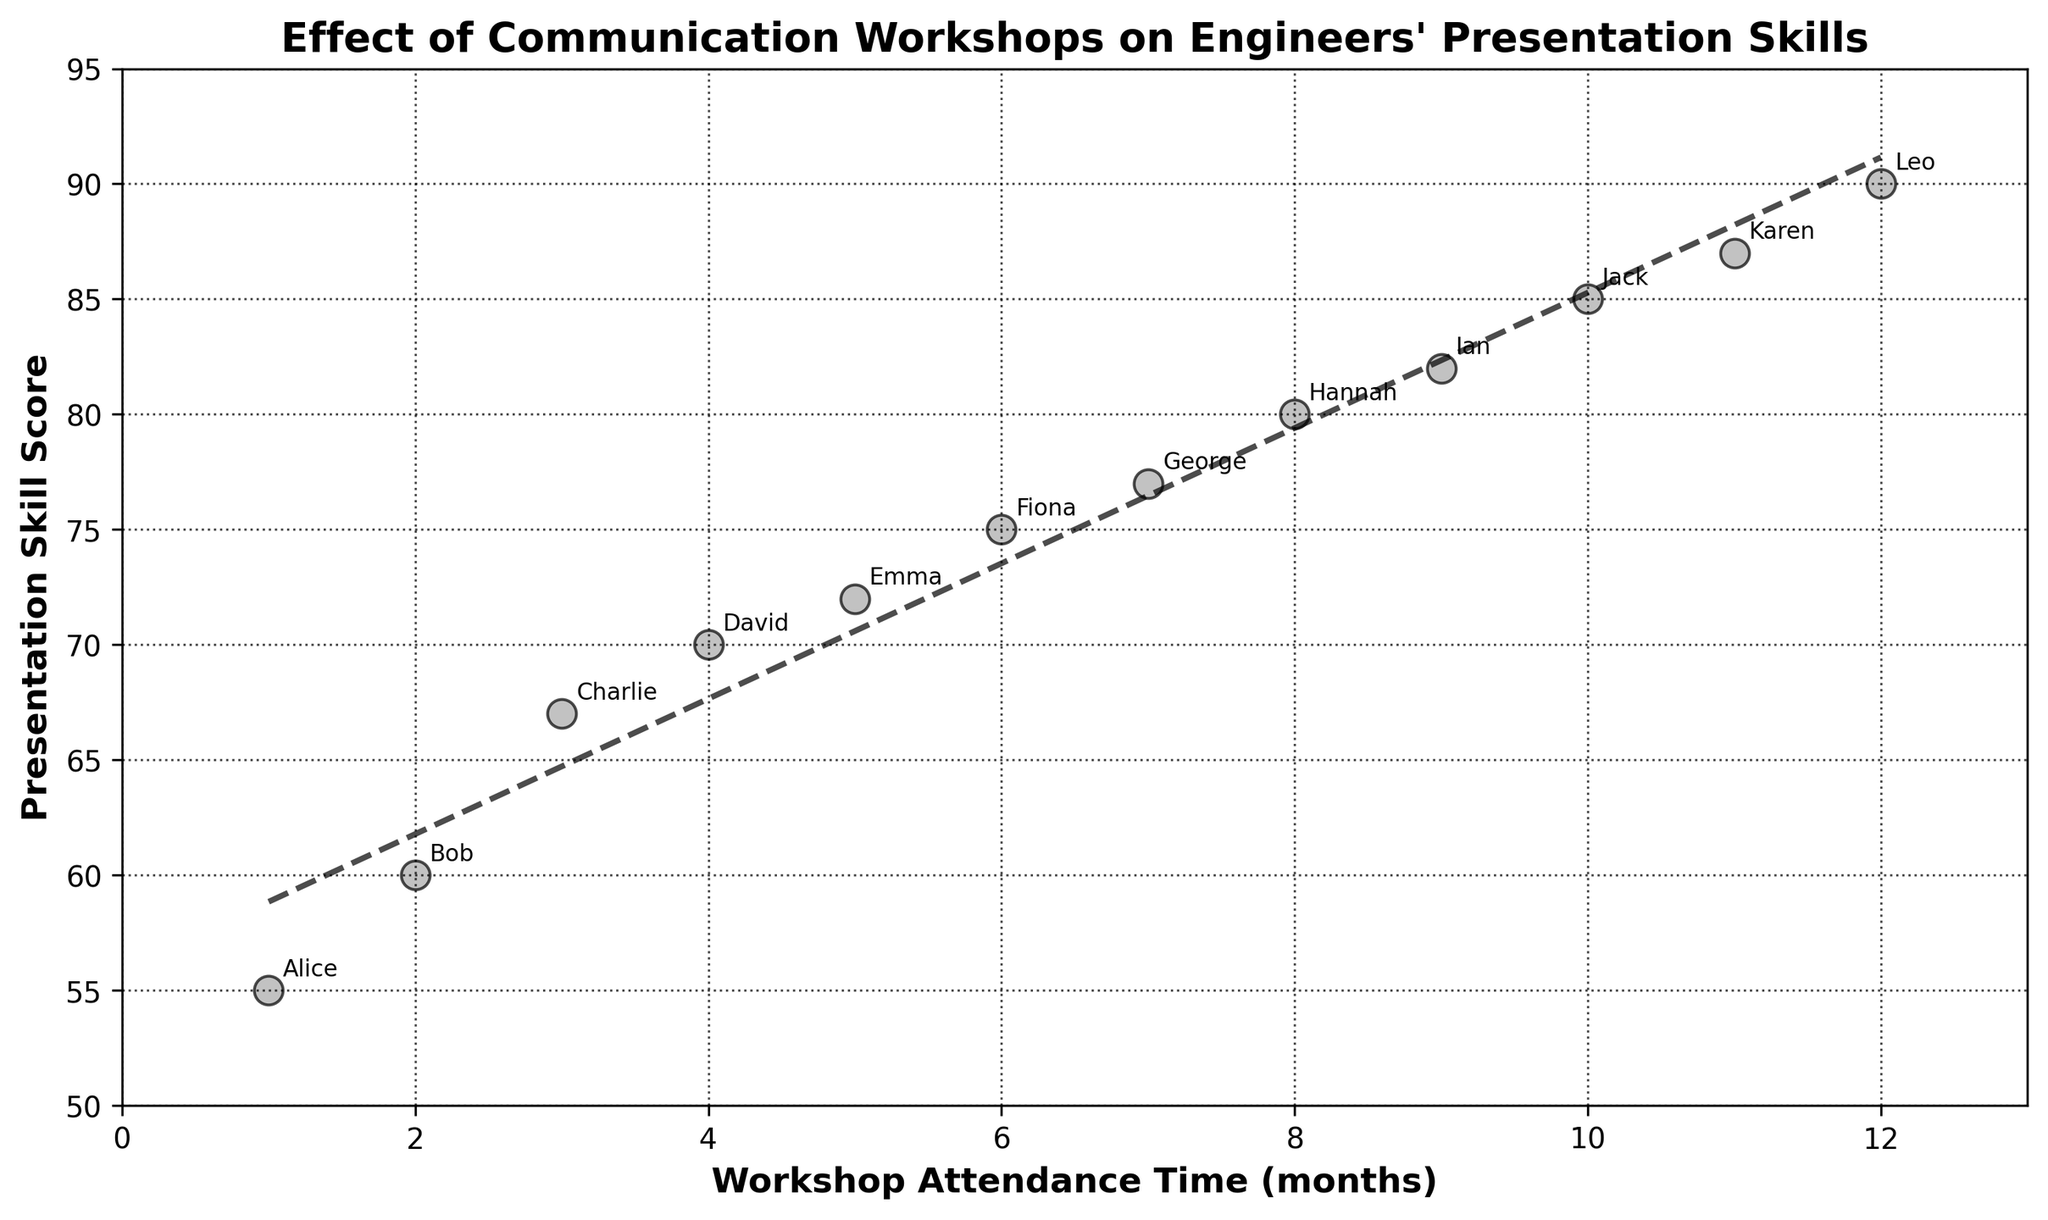What's the title of the figure? The title of the figure can be found at the top, indicating the main subject of the visualized data.
Answer: Effect of Communication Workshops on Engineers' Presentation Skills How many engineers' data are plotted in the figure? By counting the number of unique annotated names next to the data points, we determine the number of engineers.
Answer: 12 What's the maximum Presentation Skill Score depicted? Look for the highest value annotated on the y-axis or the highest data point in the scatter plot.
Answer: 90 What's the trend shown by the trend line? The trend line's slope and direction indicate whether the presentation skills are improving, declining, or staying constant over time.
Answer: Improving Which engineer attended the workshop for 6 months? Look for the annotation next to the data point where the x-axis value is 6 months.
Answer: Fiona How much did Emma's Presentation Skill Score improve from Alice's? Subtract Alice's score from Emma's score using their respective y-axis values.
Answer: 17 Who has a higher Presentation Skill Score, Bob or Jack? Compare the y-axis values for Bob and Jack by finding their annotated data points.
Answer: Jack What is the average Presentation Skill Score after attending the workshop for 7 months or more? Identify the y-axis values for data points at 7 months and beyond, then calculate their average: (77 + 80 + 82 + 85 + 87 + 90)/6.
Answer: 83.5 Which engineer shows the largest improvement in Presentation Skill Score given their duration of attending the workshop? Compare the difference between their start and end values over time. Hannah shows significant improvement from her relatively lower score to a higher score within the plotted range.
Answer: Hannah Is there any particular pattern observed from the scatter plot about the effect of workshop time on presentation skills? The scatter plot and trend line suggest a positive correlation, meaning engineers' presentation skills improve with more workshop attendance time.
Answer: Positive correlation 